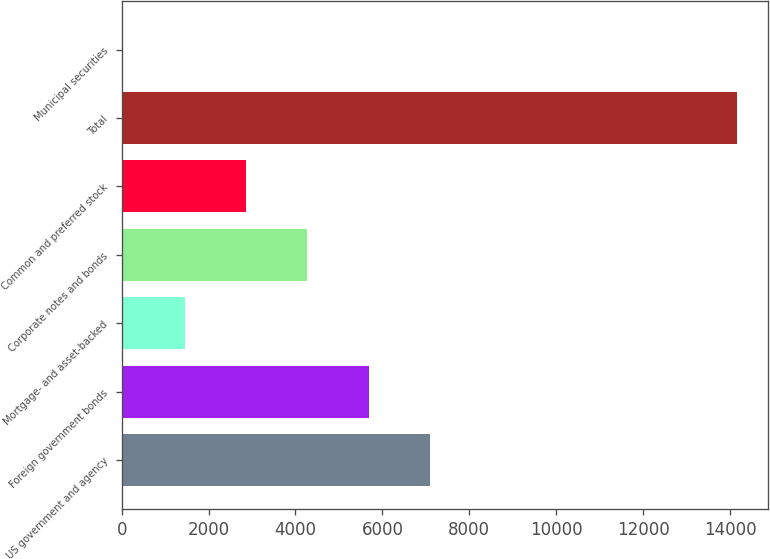<chart> <loc_0><loc_0><loc_500><loc_500><bar_chart><fcel>US government and agency<fcel>Foreign government bonds<fcel>Mortgage- and asset-backed<fcel>Corporate notes and bonds<fcel>Common and preferred stock<fcel>Total<fcel>Municipal securities<nl><fcel>7095.5<fcel>5683.6<fcel>1447.9<fcel>4271.7<fcel>2859.8<fcel>14155<fcel>36<nl></chart> 